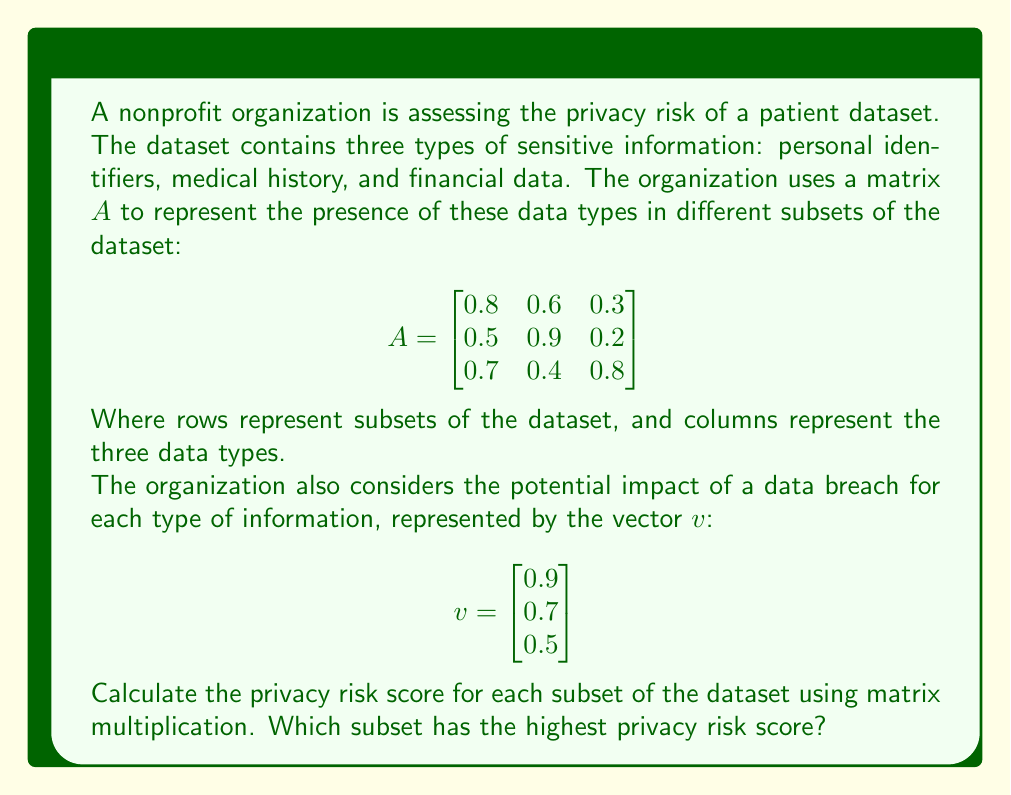Could you help me with this problem? To solve this problem, we need to perform matrix multiplication between matrix $A$ and vector $v$. This will give us a new vector containing the privacy risk scores for each subset of the dataset.

The matrix multiplication is performed as follows:

$$\text{Risk Score} = A \cdot v = \begin{bmatrix}
0.8 & 0.6 & 0.3 \\
0.5 & 0.9 & 0.2 \\
0.7 & 0.4 & 0.8
\end{bmatrix} \cdot \begin{bmatrix}
0.9 \\
0.7 \\
0.5
\end{bmatrix}$$

Let's calculate each element of the resulting vector:

1. For the first subset:
   $(0.8 \times 0.9) + (0.6 \times 0.7) + (0.3 \times 0.5) = 0.72 + 0.42 + 0.15 = 1.29$

2. For the second subset:
   $(0.5 \times 0.9) + (0.9 \times 0.7) + (0.2 \times 0.5) = 0.45 + 0.63 + 0.10 = 1.18$

3. For the third subset:
   $(0.7 \times 0.9) + (0.4 \times 0.7) + (0.8 \times 0.5) = 0.63 + 0.28 + 0.40 = 1.31$

The resulting risk score vector is:

$$\text{Risk Score} = \begin{bmatrix}
1.29 \\
1.18 \\
1.31
\end{bmatrix}$$

To determine which subset has the highest privacy risk score, we compare the values in this vector. The highest value is 1.31, corresponding to the third subset.
Answer: The privacy risk scores for each subset are:
$$\begin{bmatrix}
1.29 \\
1.18 \\
1.31
\end{bmatrix}$$
The third subset has the highest privacy risk score of 1.31. 